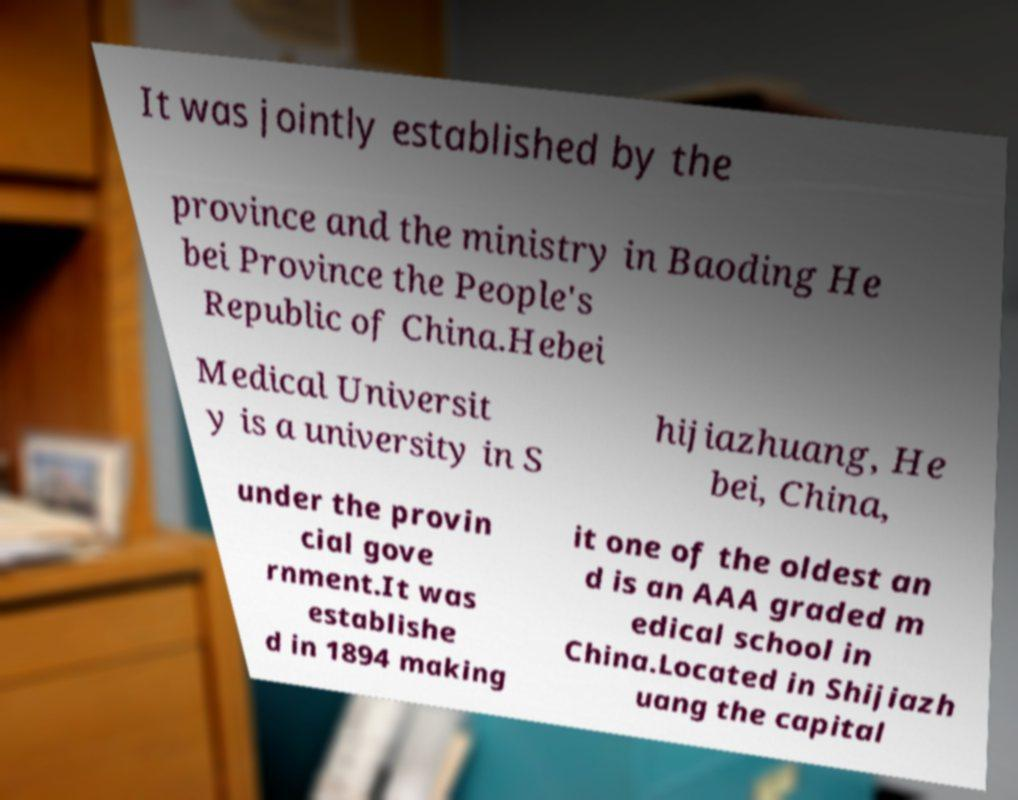Please read and relay the text visible in this image. What does it say? It was jointly established by the province and the ministry in Baoding He bei Province the People's Republic of China.Hebei Medical Universit y is a university in S hijiazhuang, He bei, China, under the provin cial gove rnment.It was establishe d in 1894 making it one of the oldest an d is an AAA graded m edical school in China.Located in Shijiazh uang the capital 